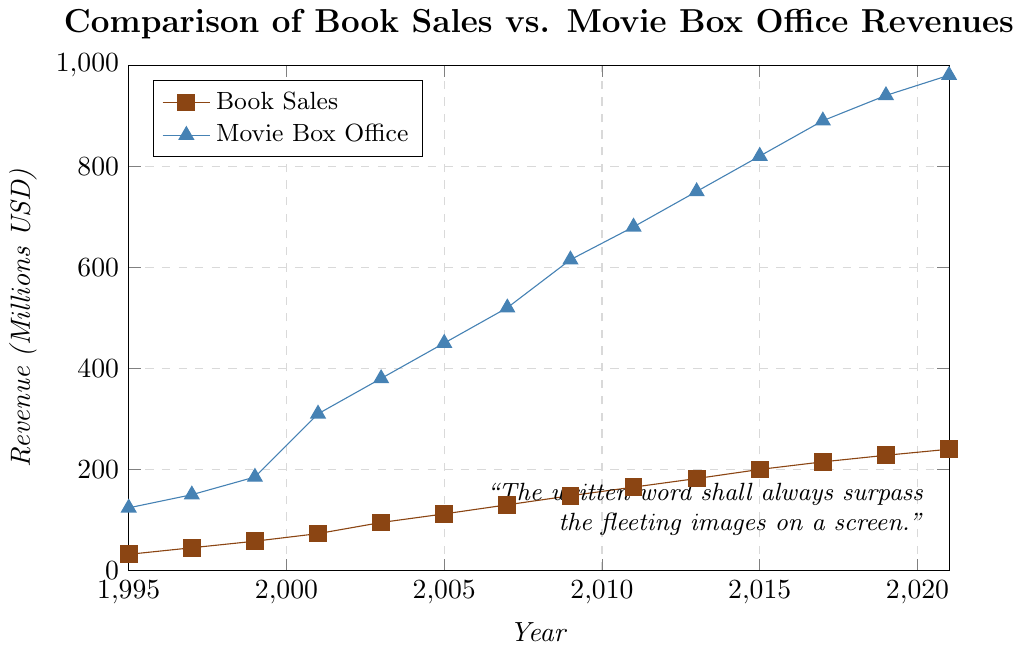What is the total revenue generated by book sales in 2015? The figure shows the book sales revenue in 2015 is $200 million.
Answer: $200 million In which year did the movie box office revenue first surpass $800 million? By observing the movie box office revenues across the years, 2015 is the first year where the movie box office revenue surpassed $800 million (indicated by it achieving $820 million).
Answer: 2015 Which year had the greatest difference between movie box office and book sales revenue? To find the greatest difference, we need to subtract book sales from movie box office revenue for each year. The greatest difference is in 2021, calculated as $980 million - $240 million = $740 million.
Answer: 2021 How does the trend of book sales compare to movie box office revenues from 1995 to 2021? Both book sales and movie box office revenues show an upward trend from 1995 to 2021. Movie box office revenues increase at a notably higher rate compared to book sales.
Answer: Both increase, movie box office more rapidly What was the percentage increase in book sales from 1995 to 2021? The book sales in 1995 were $32 million and in 2021 were $240 million. The percentage increase is calculated as ((240 - 32) / 32) * 100.
Answer: 650% Which year had the smallest gap between book sales and movie box office revenue? By examining each year's data, the smallest gap is in 1995, with $(124 million - $32 million = $92 million).
Answer: 1995 Between which consecutive years did the movie box office revenue increase the most? Determine the increase by subtracting revenues of consecutive years. The maximum increase is between 2009 and 2011, where the revenue increased from $615 million to $680 million, an increase of $195 million.
Answer: 2009-2011 What is the average annual movie box office revenue over the period? Add all the movie box office revenues and then divide by the number of years: ($124 + $150 + $185 + $310 + $380 + $450 + $520 + $615 + $680 + $750 + $820 + $890 + $940 + $980) / 14.
Answer: $526.43 million In which year did book sales reach $130 million? According to the figure, book sales reached $130 million in 2007.
Answer: 2007 Using visual elements, what colors represent book sales and movie box office revenues on the figure? The book sales are denoted by brown points and movie box office revenues by blue points.
Answer: Brown for book sales, blue for movie box office 